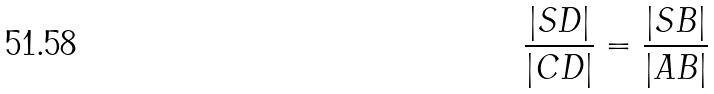Convert formula to latex. <formula><loc_0><loc_0><loc_500><loc_500>\frac { | S D | } { | C D | } = \frac { | S B | } { | A B | }</formula> 